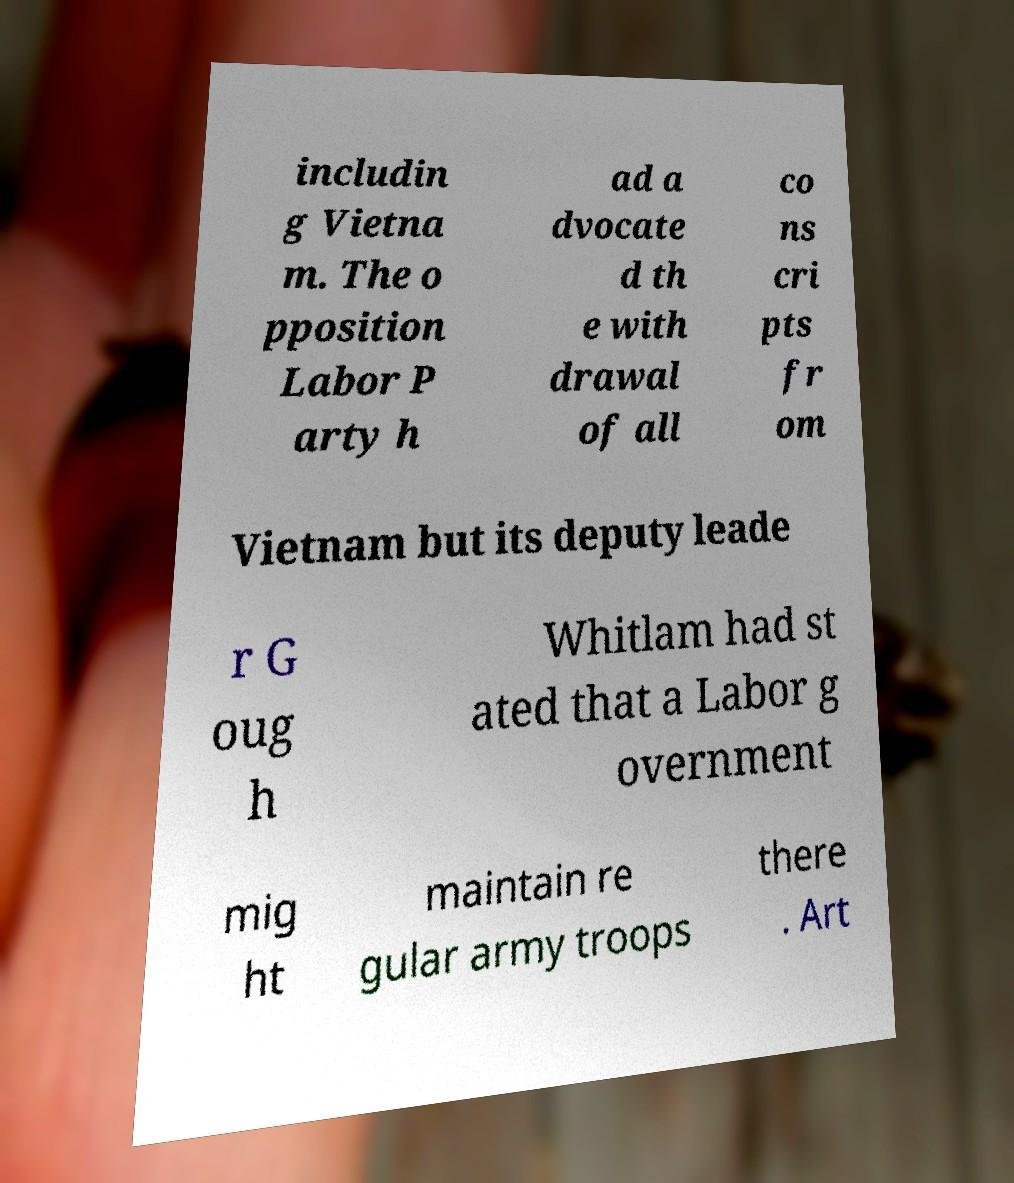Can you read and provide the text displayed in the image?This photo seems to have some interesting text. Can you extract and type it out for me? includin g Vietna m. The o pposition Labor P arty h ad a dvocate d th e with drawal of all co ns cri pts fr om Vietnam but its deputy leade r G oug h Whitlam had st ated that a Labor g overnment mig ht maintain re gular army troops there . Art 